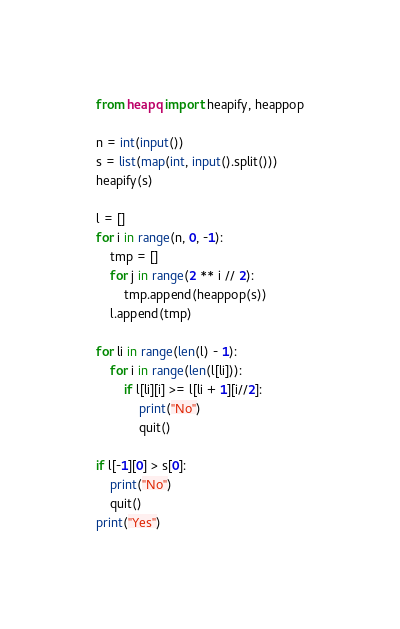<code> <loc_0><loc_0><loc_500><loc_500><_Python_>from heapq import heapify, heappop

n = int(input())
s = list(map(int, input().split()))
heapify(s)

l = []
for i in range(n, 0, -1):
    tmp = []
    for j in range(2 ** i // 2):
        tmp.append(heappop(s))
    l.append(tmp)

for li in range(len(l) - 1):
    for i in range(len(l[li])):
        if l[li][i] >= l[li + 1][i//2]:
            print("No")
            quit()

if l[-1][0] > s[0]:
    print("No")
    quit()
print("Yes")</code> 